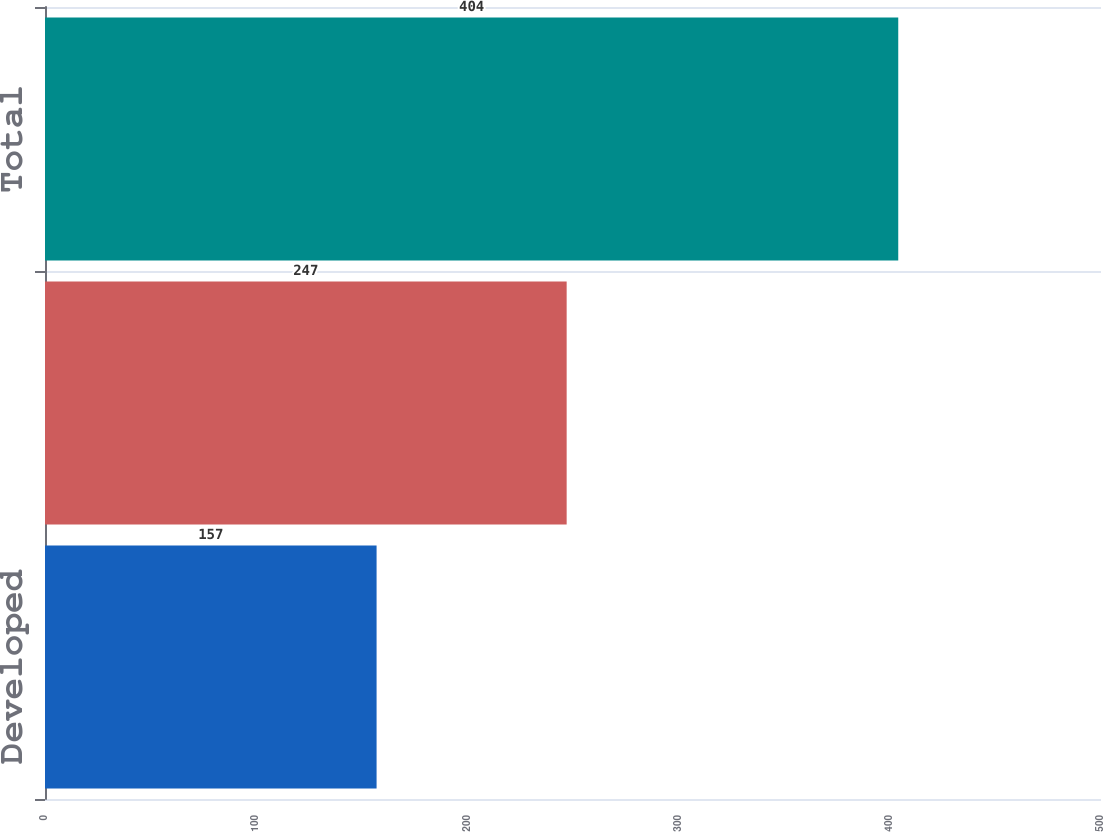Convert chart to OTSL. <chart><loc_0><loc_0><loc_500><loc_500><bar_chart><fcel>Developed<fcel>Undeveloped<fcel>Total<nl><fcel>157<fcel>247<fcel>404<nl></chart> 